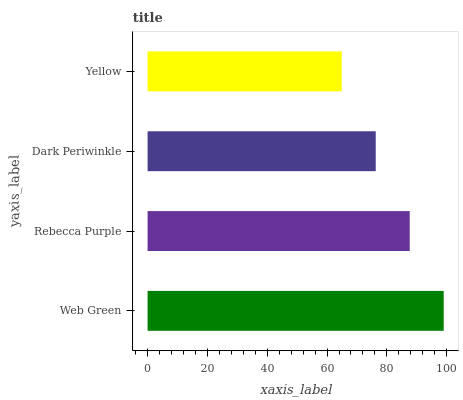Is Yellow the minimum?
Answer yes or no. Yes. Is Web Green the maximum?
Answer yes or no. Yes. Is Rebecca Purple the minimum?
Answer yes or no. No. Is Rebecca Purple the maximum?
Answer yes or no. No. Is Web Green greater than Rebecca Purple?
Answer yes or no. Yes. Is Rebecca Purple less than Web Green?
Answer yes or no. Yes. Is Rebecca Purple greater than Web Green?
Answer yes or no. No. Is Web Green less than Rebecca Purple?
Answer yes or no. No. Is Rebecca Purple the high median?
Answer yes or no. Yes. Is Dark Periwinkle the low median?
Answer yes or no. Yes. Is Web Green the high median?
Answer yes or no. No. Is Yellow the low median?
Answer yes or no. No. 